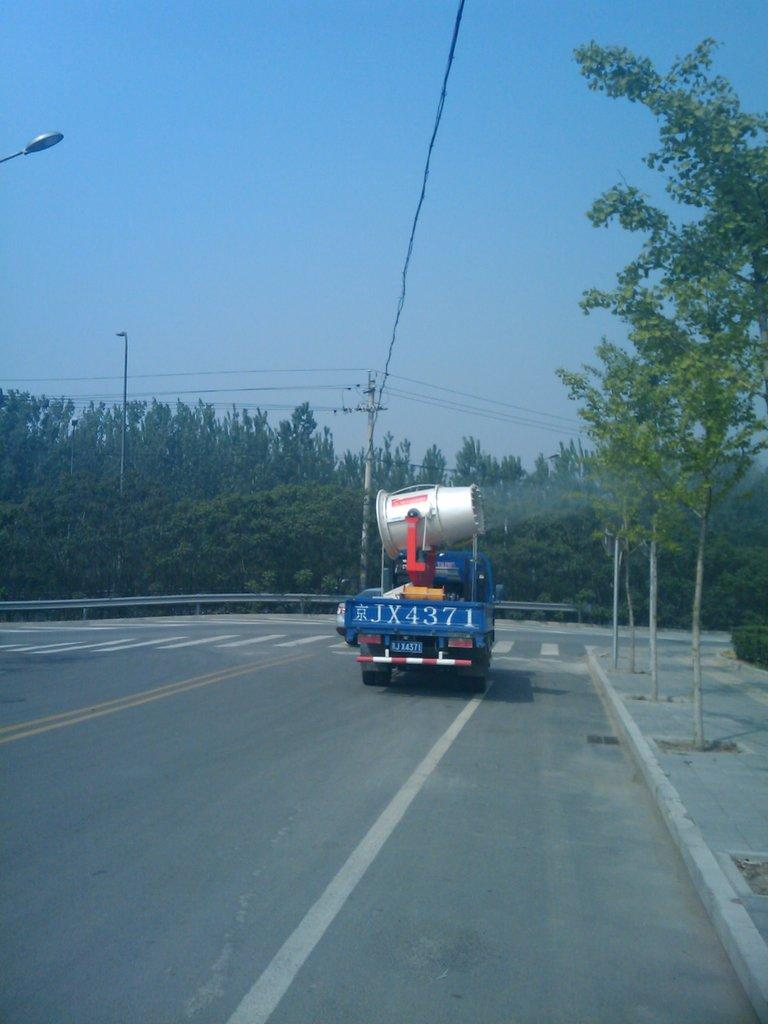What is on the road in the image? There is a vehicle on the road in the image. What type of natural elements can be seen in the image? There are trees visible in the image. What structures are present in the image? There are poles in the image. What can be seen attached to the poles? There are lights and cables in the image. What type of cord is being used in the image? There is no cord present in the image. 